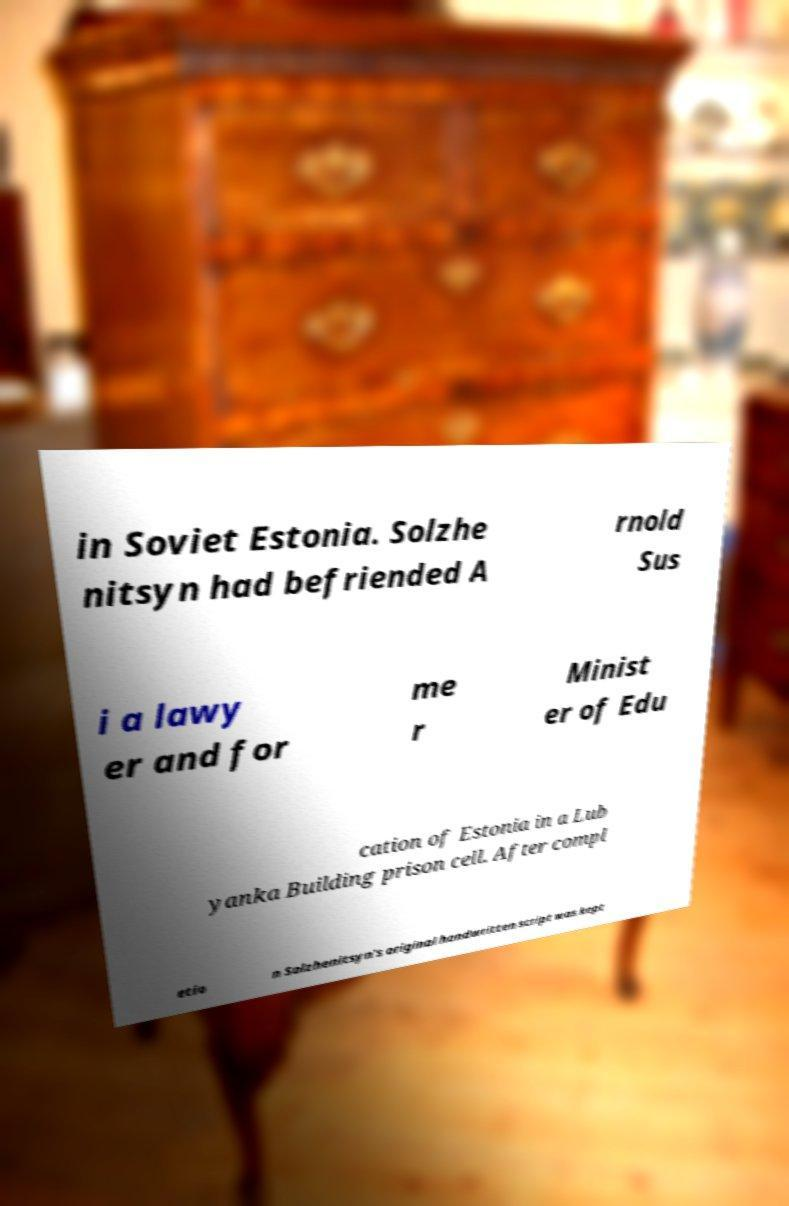For documentation purposes, I need the text within this image transcribed. Could you provide that? in Soviet Estonia. Solzhe nitsyn had befriended A rnold Sus i a lawy er and for me r Minist er of Edu cation of Estonia in a Lub yanka Building prison cell. After compl etio n Solzhenitsyn's original handwritten script was kept 